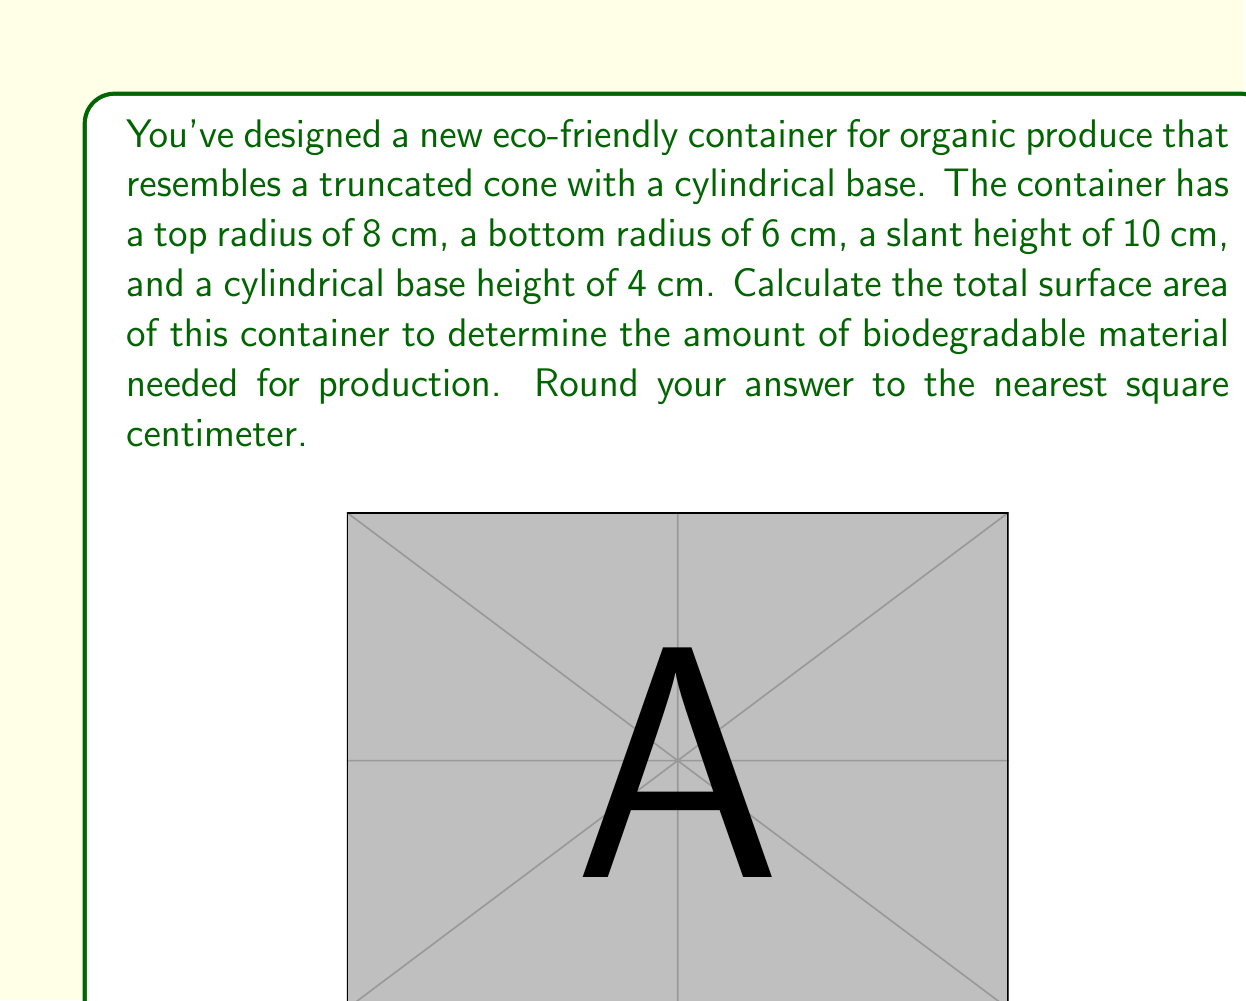Could you help me with this problem? To solve this problem, we need to calculate the surface area of each part of the container and sum them up:

1) The lateral surface area of the truncated cone:
   $$A_l = \pi(r_1 + r_2)s$$
   where $r_1$ is the bottom radius, $r_2$ is the top radius, and $s$ is the slant height.

2) The area of the top circular face:
   $$A_t = \pi r_2^2$$

3) The lateral surface area of the cylindrical base:
   $$A_c = 2\pi r_1 h$$
   where $h$ is the height of the cylindrical base.

4) The area of the bottom circular face:
   $$A_b = \pi r_1^2$$

Step 1: Calculate the lateral surface area of the truncated cone
$$A_l = \pi(6 + 8) \cdot 10 = 140\pi \approx 439.82 \text{ cm}^2$$

Step 2: Calculate the area of the top circular face
$$A_t = \pi \cdot 8^2 = 64\pi \approx 201.06 \text{ cm}^2$$

Step 3: Calculate the lateral surface area of the cylindrical base
$$A_c = 2\pi \cdot 6 \cdot 4 = 48\pi \approx 150.80 \text{ cm}^2$$

Step 4: Calculate the area of the bottom circular face
$$A_b = \pi \cdot 6^2 = 36\pi \approx 113.10 \text{ cm}^2$$

Step 5: Sum up all the areas
$$A_{total} = A_l + A_t + A_c + A_b$$
$$A_{total} = 439.82 + 201.06 + 150.80 + 113.10 = 904.78 \text{ cm}^2$$

Step 6: Round to the nearest square centimeter
$$A_{total} \approx 905 \text{ cm}^2$$
Answer: 905 cm² 